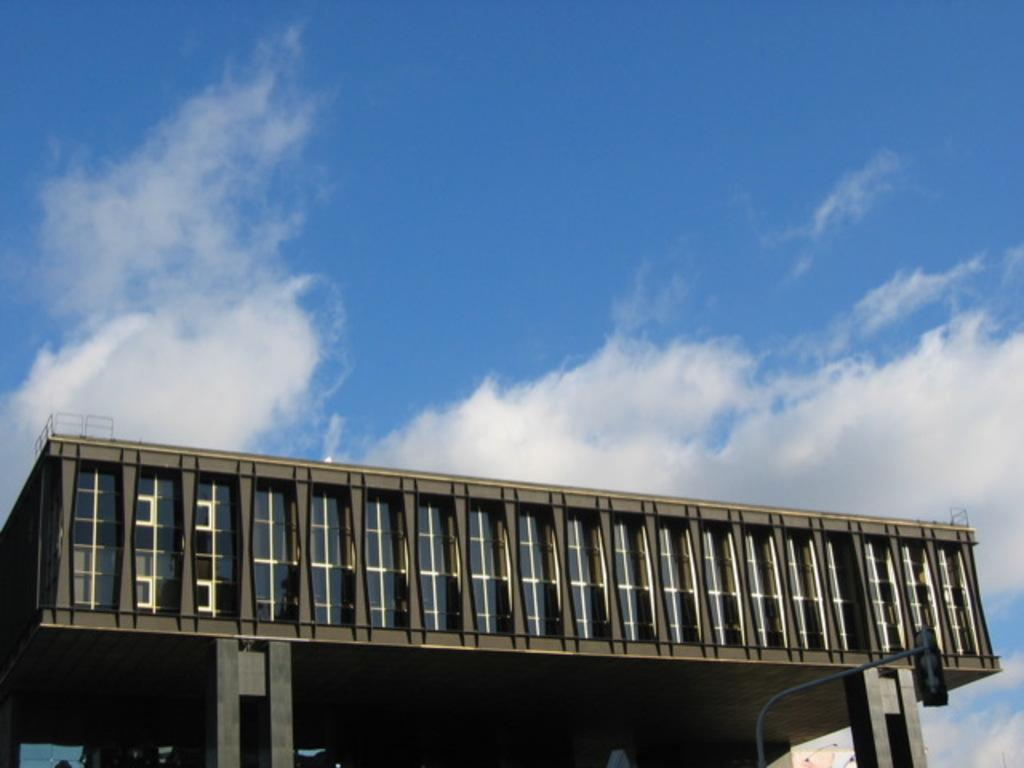What type of structure is present in the image? There is a building in the image. What other object can be seen in the image? There is a pole in the image. Can you describe the objects in the image? There are some objects in the image. What is visible in the background of the image? The sky is visible in the background of the image. What type of work is being done with the rake in the image? There is no rake present in the image. Can you tell me who placed the order for the objects in the image? There is no reference to an order or any purchasing activity in the image. 